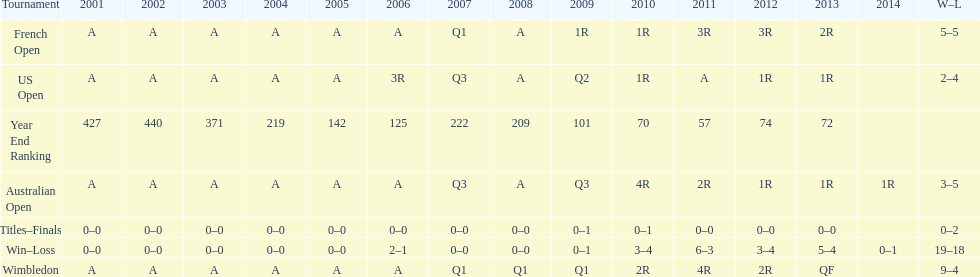In which years were there only 1 loss? 2006, 2009, 2014. 